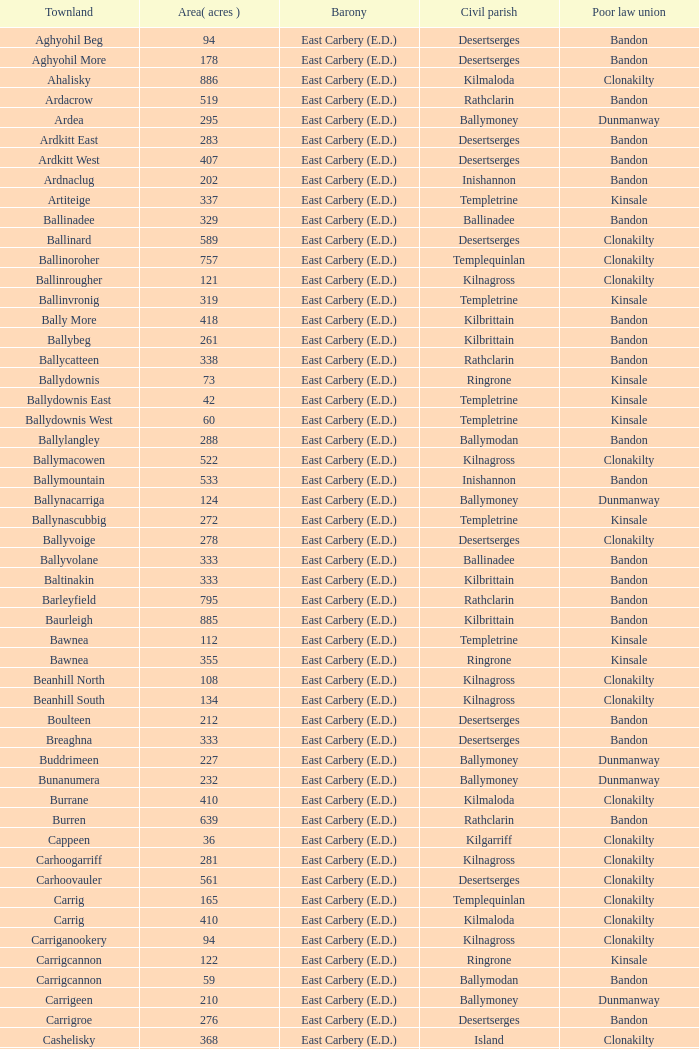What is the impoverished law association of the ardacrow townland? Bandon. 